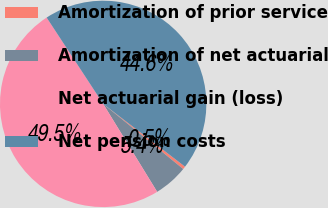Convert chart to OTSL. <chart><loc_0><loc_0><loc_500><loc_500><pie_chart><fcel>Amortization of prior service<fcel>Amortization of net actuarial<fcel>Net actuarial gain (loss)<fcel>Net pension costs<nl><fcel>0.46%<fcel>5.36%<fcel>49.54%<fcel>44.64%<nl></chart> 